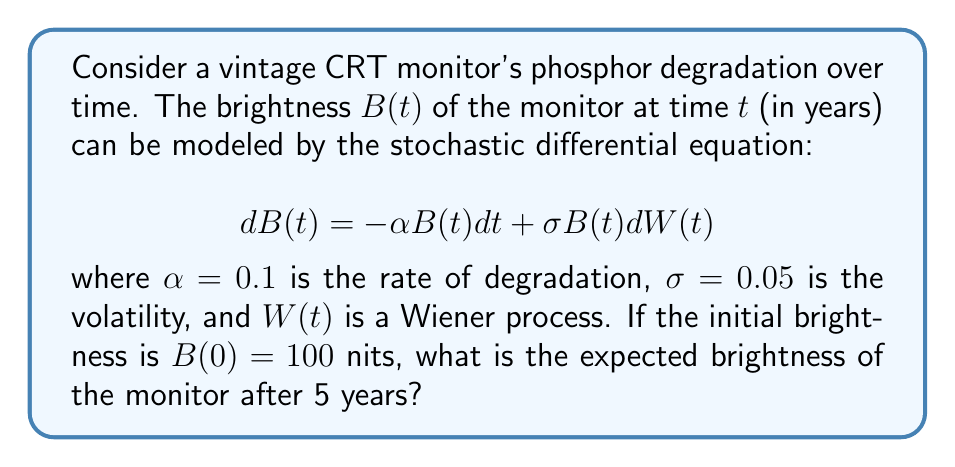Provide a solution to this math problem. To solve this problem, we need to follow these steps:

1) The given stochastic differential equation is a geometric Brownian motion model. For such models, the expected value of $B(t)$ is given by:

   $$E[B(t)] = B(0)e^{(\alpha - \frac{1}{2}\sigma^2)t}$$

2) We are given:
   - $B(0) = 100$ nits (initial brightness)
   - $\alpha = 0.1$ (rate of degradation)
   - $\sigma = 0.05$ (volatility)
   - $t = 5$ years

3) Let's substitute these values into the formula:

   $$E[B(5)] = 100 \cdot e^{(0.1 - \frac{1}{2}(0.05)^2) \cdot 5}$$

4) Simplify the exponent:
   
   $$0.1 - \frac{1}{2}(0.05)^2 = 0.1 - 0.00125 = 0.09875$$

5) Now we have:

   $$E[B(5)] = 100 \cdot e^{0.09875 \cdot 5} = 100 \cdot e^{0.49375}$$

6) Calculate the final result:

   $$E[B(5)] = 100 \cdot 1.6384 = 163.84$$

Therefore, the expected brightness after 5 years is approximately 163.84 nits.
Answer: 163.84 nits 